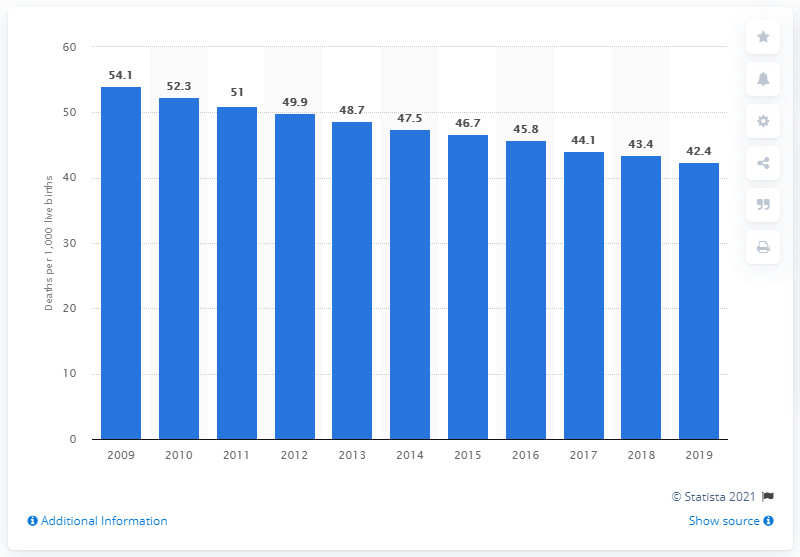Highlight a few significant elements in this photo. The infant mortality rate in Zambia in 2019 was 42.4. 